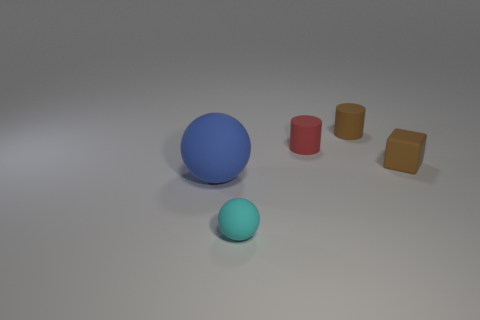How many tiny objects are to the right of the small red cylinder behind the matte ball behind the tiny cyan object?
Make the answer very short. 2. Are there any brown cylinders in front of the red rubber thing?
Your answer should be very brief. No. What number of other large blue balls are the same material as the big ball?
Provide a short and direct response. 0. What number of objects are either tiny brown blocks or tiny spheres?
Ensure brevity in your answer.  2. Is there a blue matte thing?
Offer a terse response. Yes. What is the object that is left of the rubber thing that is in front of the object on the left side of the small cyan matte object made of?
Give a very brief answer. Rubber. Are there fewer cyan objects that are behind the large blue rubber ball than small brown cubes?
Provide a succinct answer. Yes. What size is the rubber thing that is both in front of the red matte cylinder and on the right side of the tiny rubber sphere?
Offer a very short reply. Small. The blue thing that is the same shape as the small cyan thing is what size?
Offer a very short reply. Large. How many objects are big metal cylinders or matte things in front of the tiny brown cube?
Provide a short and direct response. 2. 